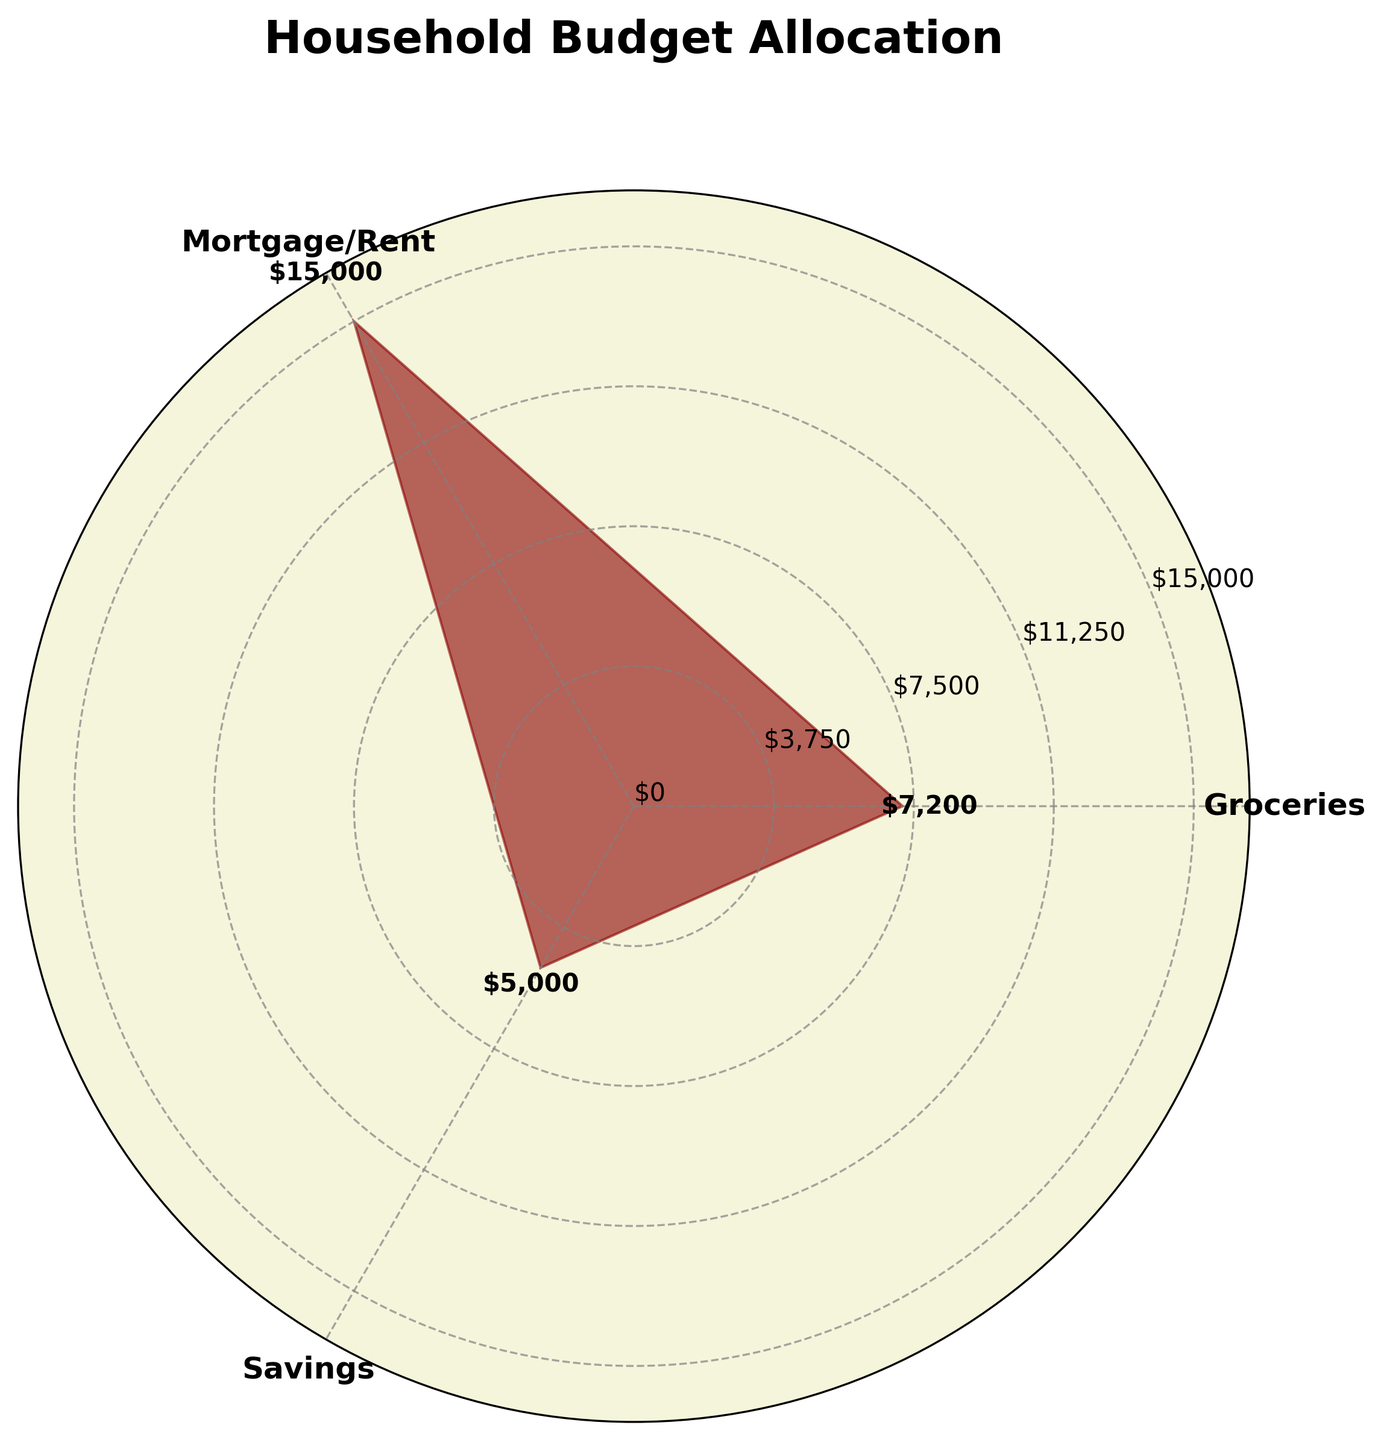What is the title of the chart? The title of the chart is written at the top and is easy to read.
Answer: Household Budget Allocation How many categories of expenditures are displayed? Count the number of different expenditure categories in the chart.
Answer: 3 Which expenditure category has the highest allocation? Identify which section of the polar area chart extends furthest from the center.
Answer: Mortgage/Rent What color is used to fill the areas representing expenditures? Observe the filling color used in the areas of the chart.
Answer: Dark red What is the total annual expenditure for all categories combined? Add up the expenditure values for all categories provided. 7200 (Groceries) + 15000 (Mortgage/Rent) + 5000 (Savings)
Answer: 27200 What is the percentage of the total budget allocated to savings? Calculate the percentage by dividing the savings amount by the total expenditure and multiplying by 100. (5000 / 27200) * 100
Answer: 18.38% How does the expenditure on groceries compare to that on savings? Compare the values of groceries and savings visually and numerically. 7200 (Groceries) and 5000 (Savings)
Answer: Groceries > Savings What is the average expenditure per category? Divide the total expenditure by the number of categories. 27200 / 3
Answer: 9066.67 If a new category, 'Utilities,' with an annual expenditure of $3800 is added, what will be the new total budget? Add the new expenditure to the current total expenditure. 27200 + 3800
Answer: 31000 